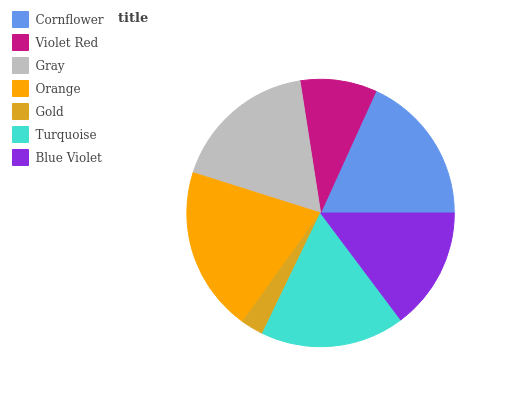Is Gold the minimum?
Answer yes or no. Yes. Is Orange the maximum?
Answer yes or no. Yes. Is Violet Red the minimum?
Answer yes or no. No. Is Violet Red the maximum?
Answer yes or no. No. Is Cornflower greater than Violet Red?
Answer yes or no. Yes. Is Violet Red less than Cornflower?
Answer yes or no. Yes. Is Violet Red greater than Cornflower?
Answer yes or no. No. Is Cornflower less than Violet Red?
Answer yes or no. No. Is Turquoise the high median?
Answer yes or no. Yes. Is Turquoise the low median?
Answer yes or no. Yes. Is Gray the high median?
Answer yes or no. No. Is Orange the low median?
Answer yes or no. No. 